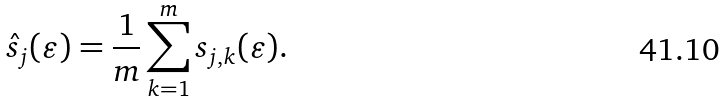Convert formula to latex. <formula><loc_0><loc_0><loc_500><loc_500>\hat { s } _ { j } ( \varepsilon ) = \frac { 1 } { m } \sum _ { k = 1 } ^ { m } s _ { j , k } ( \varepsilon ) .</formula> 